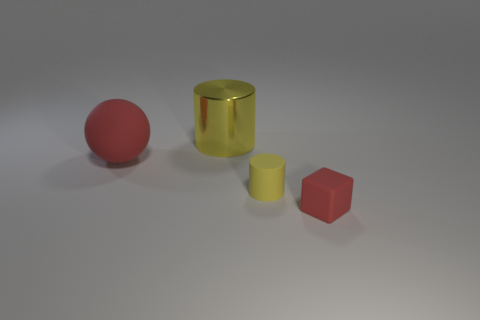Add 2 tiny red blocks. How many objects exist? 6 Subtract all cubes. How many objects are left? 3 Add 4 large red metallic cylinders. How many large red metallic cylinders exist? 4 Subtract 0 yellow spheres. How many objects are left? 4 Subtract all gray matte cylinders. Subtract all yellow rubber objects. How many objects are left? 3 Add 4 big metal things. How many big metal things are left? 5 